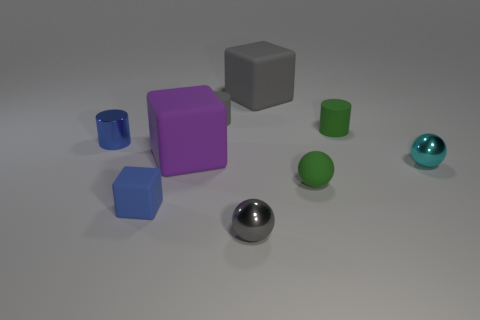Are there the same number of small gray metal things that are to the right of the tiny green sphere and small blue cylinders that are on the left side of the tiny gray metallic ball?
Ensure brevity in your answer.  No. Is the shape of the green matte thing right of the matte ball the same as the tiny green object in front of the purple matte block?
Provide a short and direct response. No. Is there anything else that is the same shape as the small blue metal object?
Offer a very short reply. Yes. The cyan object that is the same material as the small blue cylinder is what shape?
Your answer should be compact. Sphere. Are there the same number of green matte cylinders that are in front of the green sphere and small purple matte cylinders?
Offer a terse response. Yes. Is the material of the small gray thing behind the small metallic cylinder the same as the tiny gray thing in front of the large purple matte thing?
Make the answer very short. No. The big thing in front of the green thing behind the tiny cyan metallic sphere is what shape?
Make the answer very short. Cube. There is another big object that is made of the same material as the purple object; what color is it?
Provide a short and direct response. Gray. Is the color of the small metal cylinder the same as the small rubber cube?
Ensure brevity in your answer.  Yes. The blue shiny object that is the same size as the cyan object is what shape?
Offer a very short reply. Cylinder. 